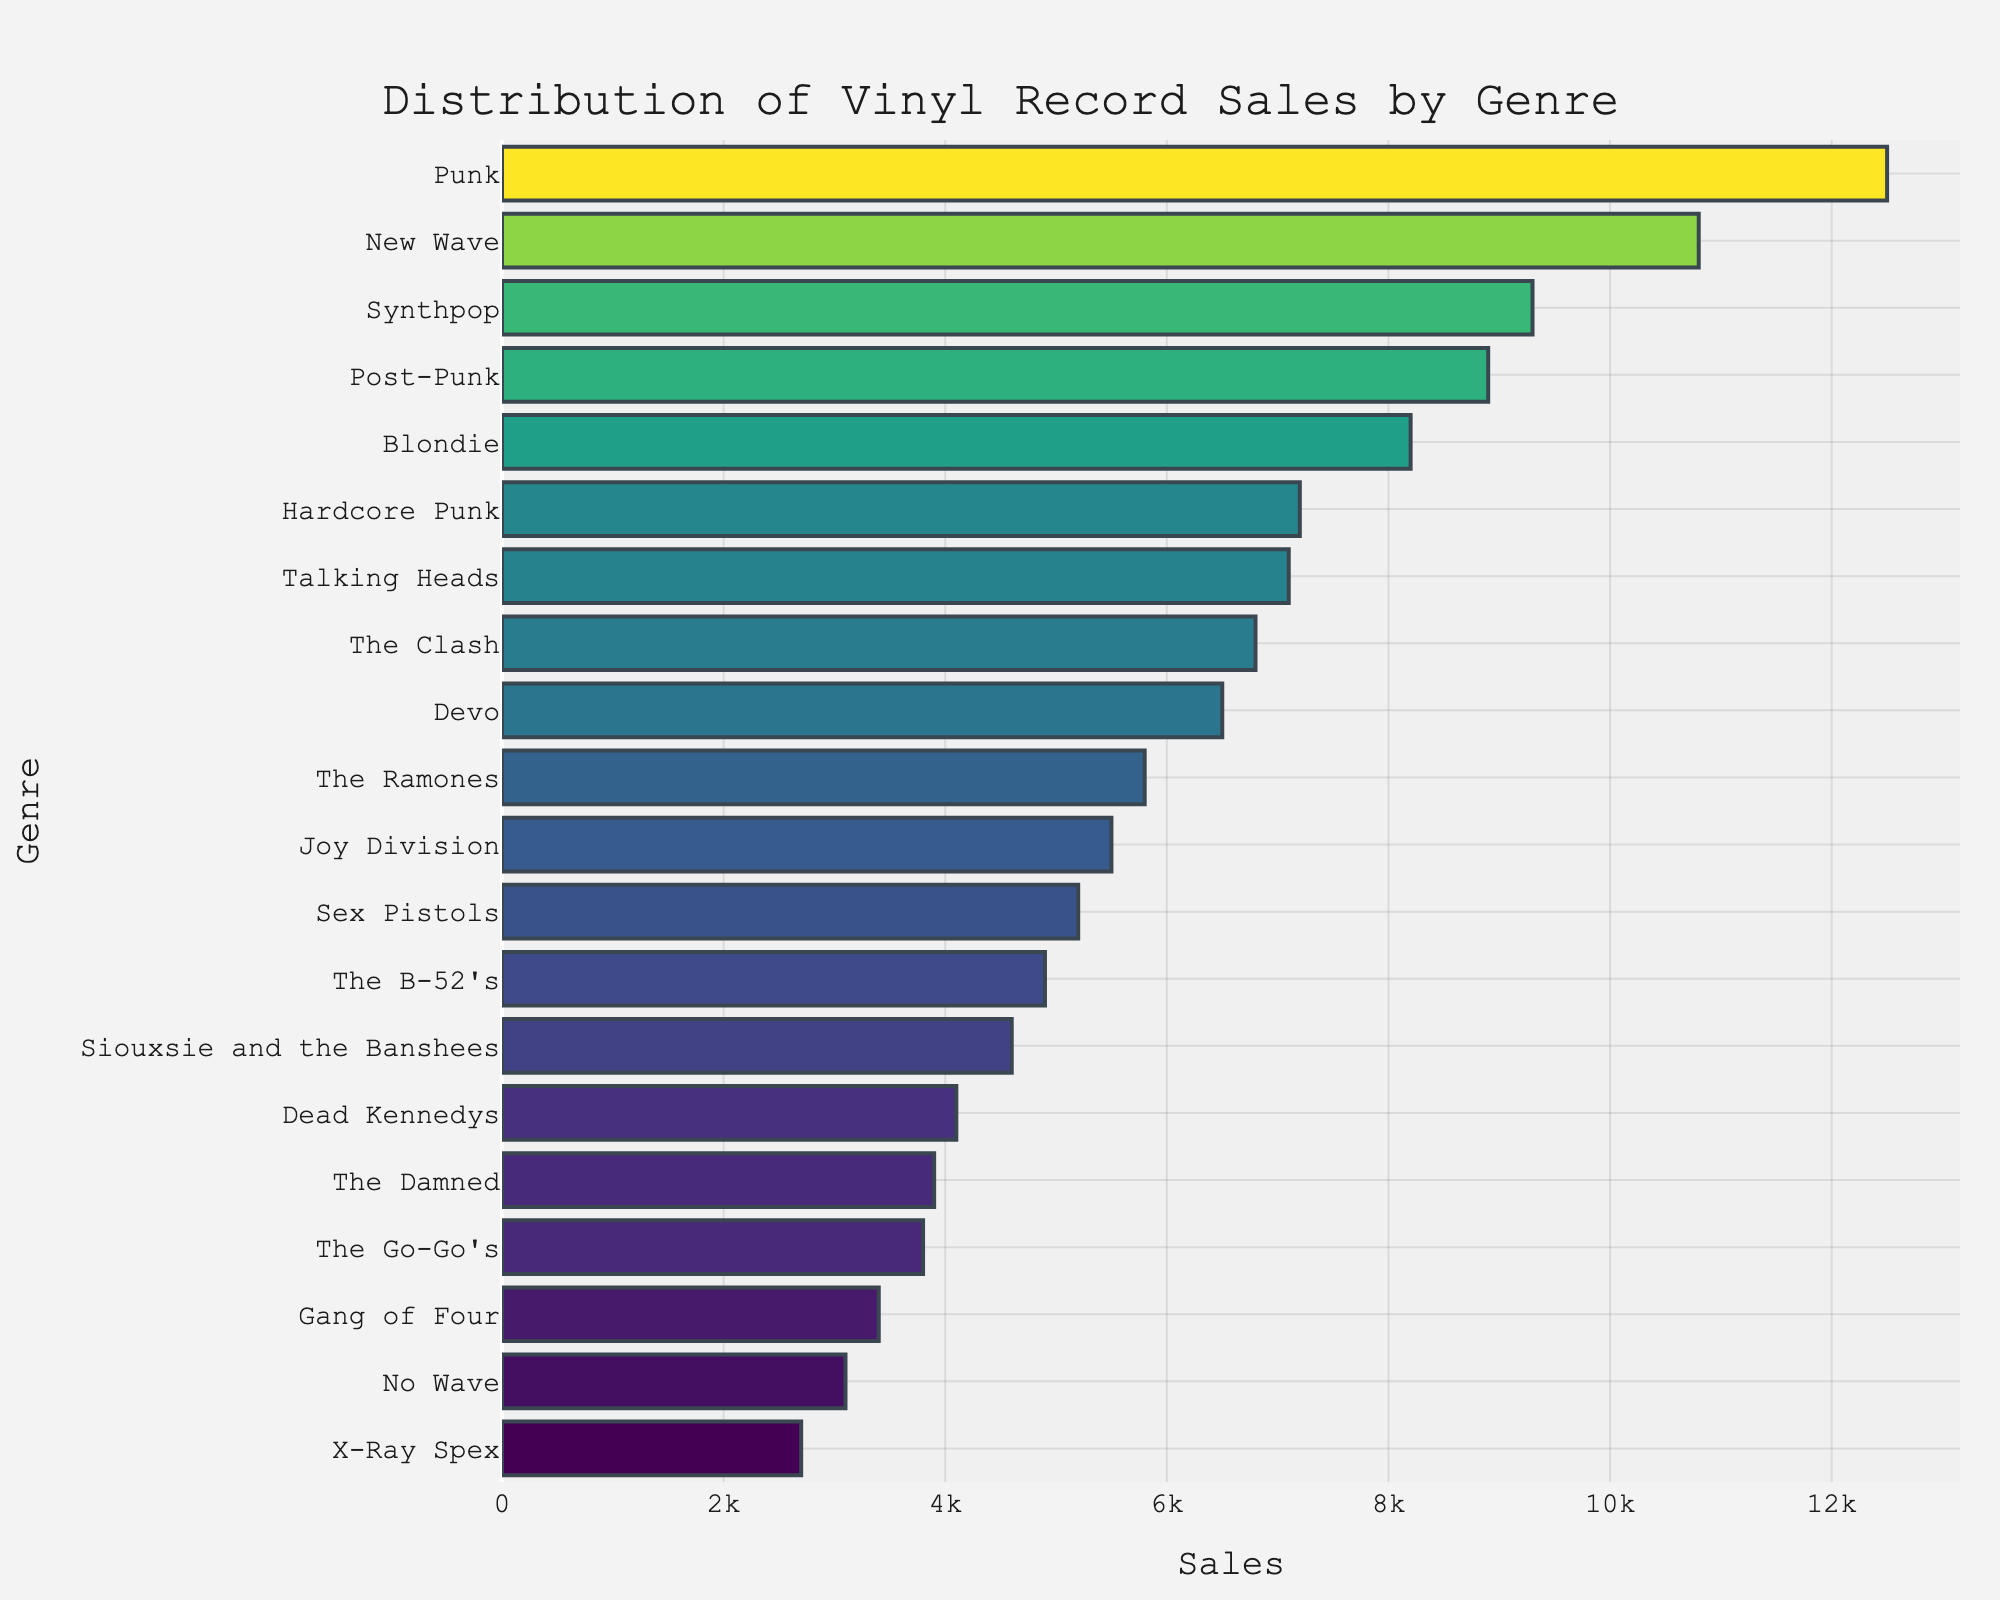what's the title of the plot? The title is usually found at the top of the figure. In this case, it's placed with a specific formatting. The title is: "Distribution of Vinyl Record Sales by Genre"
Answer: Distribution of Vinyl Record Sales by Genre which genre has the highest vinyl record sales? The genre with the longest horizontal bar has the highest sales. Punk has the longest bar, and thus the highest sales in the plot.
Answer: Punk how many genres have vinyl record sales over 8000? Count the bars where the sales figures exceed 8000. Those genres are Punk, New Wave, Post-Punk, and Synthpop. That's 4 genres in total.
Answer: 4 what's the total sale combining New Wave and Synthpop? Find the sales for New Wave and Synthpop, then add them together. New Wave = 10800 and Synthpop = 9300. So, 10800 + 9300 = 20100.
Answer: 20100 is Joy Division's vinyl record sales higher or lower than Siouxsie and the Banshees? Compare the lengths of their respective bars or directly the sales numbers. Joy Division has 5500 while Siouxsie and the Banshees have 4600. Joy Division's sales are higher.
Answer: Higher which has more sales, Hardcore Punk or Talking Heads? Compare their sales values. Hardcore Punk has 7200, and Talking Heads has 7100. So, Hardcore Punk has more sales.
Answer: Hardcore Punk what's the average sales of Devo, The Ramones, and The Clash? Calculate the average by summing their sales and dividing by 3. Devo = 6500, The Ramones = 5800, and The Clash = 6800. So, (6500 + 5800 + 6800) / 3 = 19000 / 3 ≈ 6333.33
Answer: 6333.33 what's the genre with the least vinyl record sales? The genre with the shortest bar represents the least sales. No Wave, with a value of 3100, has the least sales.
Answer: No Wave how do the sales of Gang of Four compare to The Damned? Compare their sales numbers directly. Gang of Four has 3400, and The Damned has 3900. The Damned’s sales are higher than Gang of Four’s.
Answer: The Damned 